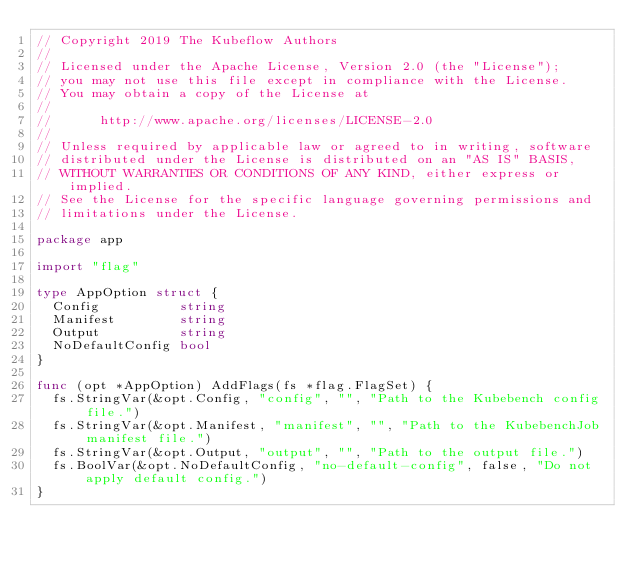<code> <loc_0><loc_0><loc_500><loc_500><_Go_>// Copyright 2019 The Kubeflow Authors
//
// Licensed under the Apache License, Version 2.0 (the "License");
// you may not use this file except in compliance with the License.
// You may obtain a copy of the License at
//
//      http://www.apache.org/licenses/LICENSE-2.0
//
// Unless required by applicable law or agreed to in writing, software
// distributed under the License is distributed on an "AS IS" BASIS,
// WITHOUT WARRANTIES OR CONDITIONS OF ANY KIND, either express or implied.
// See the License for the specific language governing permissions and
// limitations under the License.

package app

import "flag"

type AppOption struct {
	Config          string
	Manifest        string
	Output          string
	NoDefaultConfig bool
}

func (opt *AppOption) AddFlags(fs *flag.FlagSet) {
	fs.StringVar(&opt.Config, "config", "", "Path to the Kubebench config file.")
	fs.StringVar(&opt.Manifest, "manifest", "", "Path to the KubebenchJob manifest file.")
	fs.StringVar(&opt.Output, "output", "", "Path to the output file.")
	fs.BoolVar(&opt.NoDefaultConfig, "no-default-config", false, "Do not apply default config.")
}
</code> 